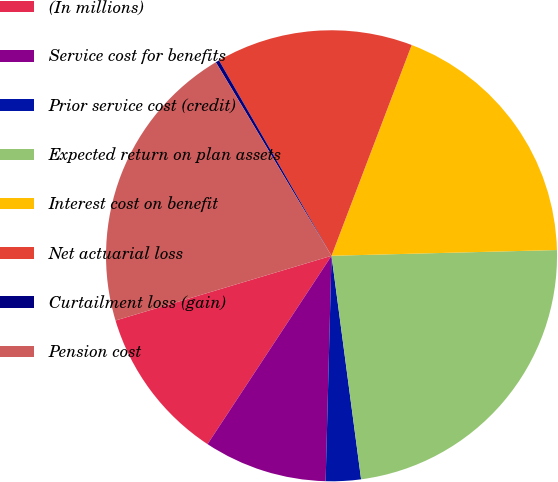Convert chart. <chart><loc_0><loc_0><loc_500><loc_500><pie_chart><fcel>(In millions)<fcel>Service cost for benefits<fcel>Prior service cost (credit)<fcel>Expected return on plan assets<fcel>Interest cost on benefit<fcel>Net actuarial loss<fcel>Curtailment loss (gain)<fcel>Pension cost<nl><fcel>11.1%<fcel>8.85%<fcel>2.51%<fcel>23.31%<fcel>18.81%<fcel>14.1%<fcel>0.26%<fcel>21.06%<nl></chart> 